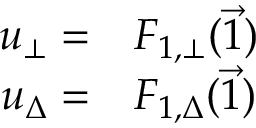<formula> <loc_0><loc_0><loc_500><loc_500>\begin{array} { r l } { u _ { \bot } = } & F _ { 1 , \bot } ( \vec { 1 } ) } \\ { u _ { \Delta } = } & F _ { 1 , \Delta } ( \vec { 1 } ) } \end{array}</formula> 